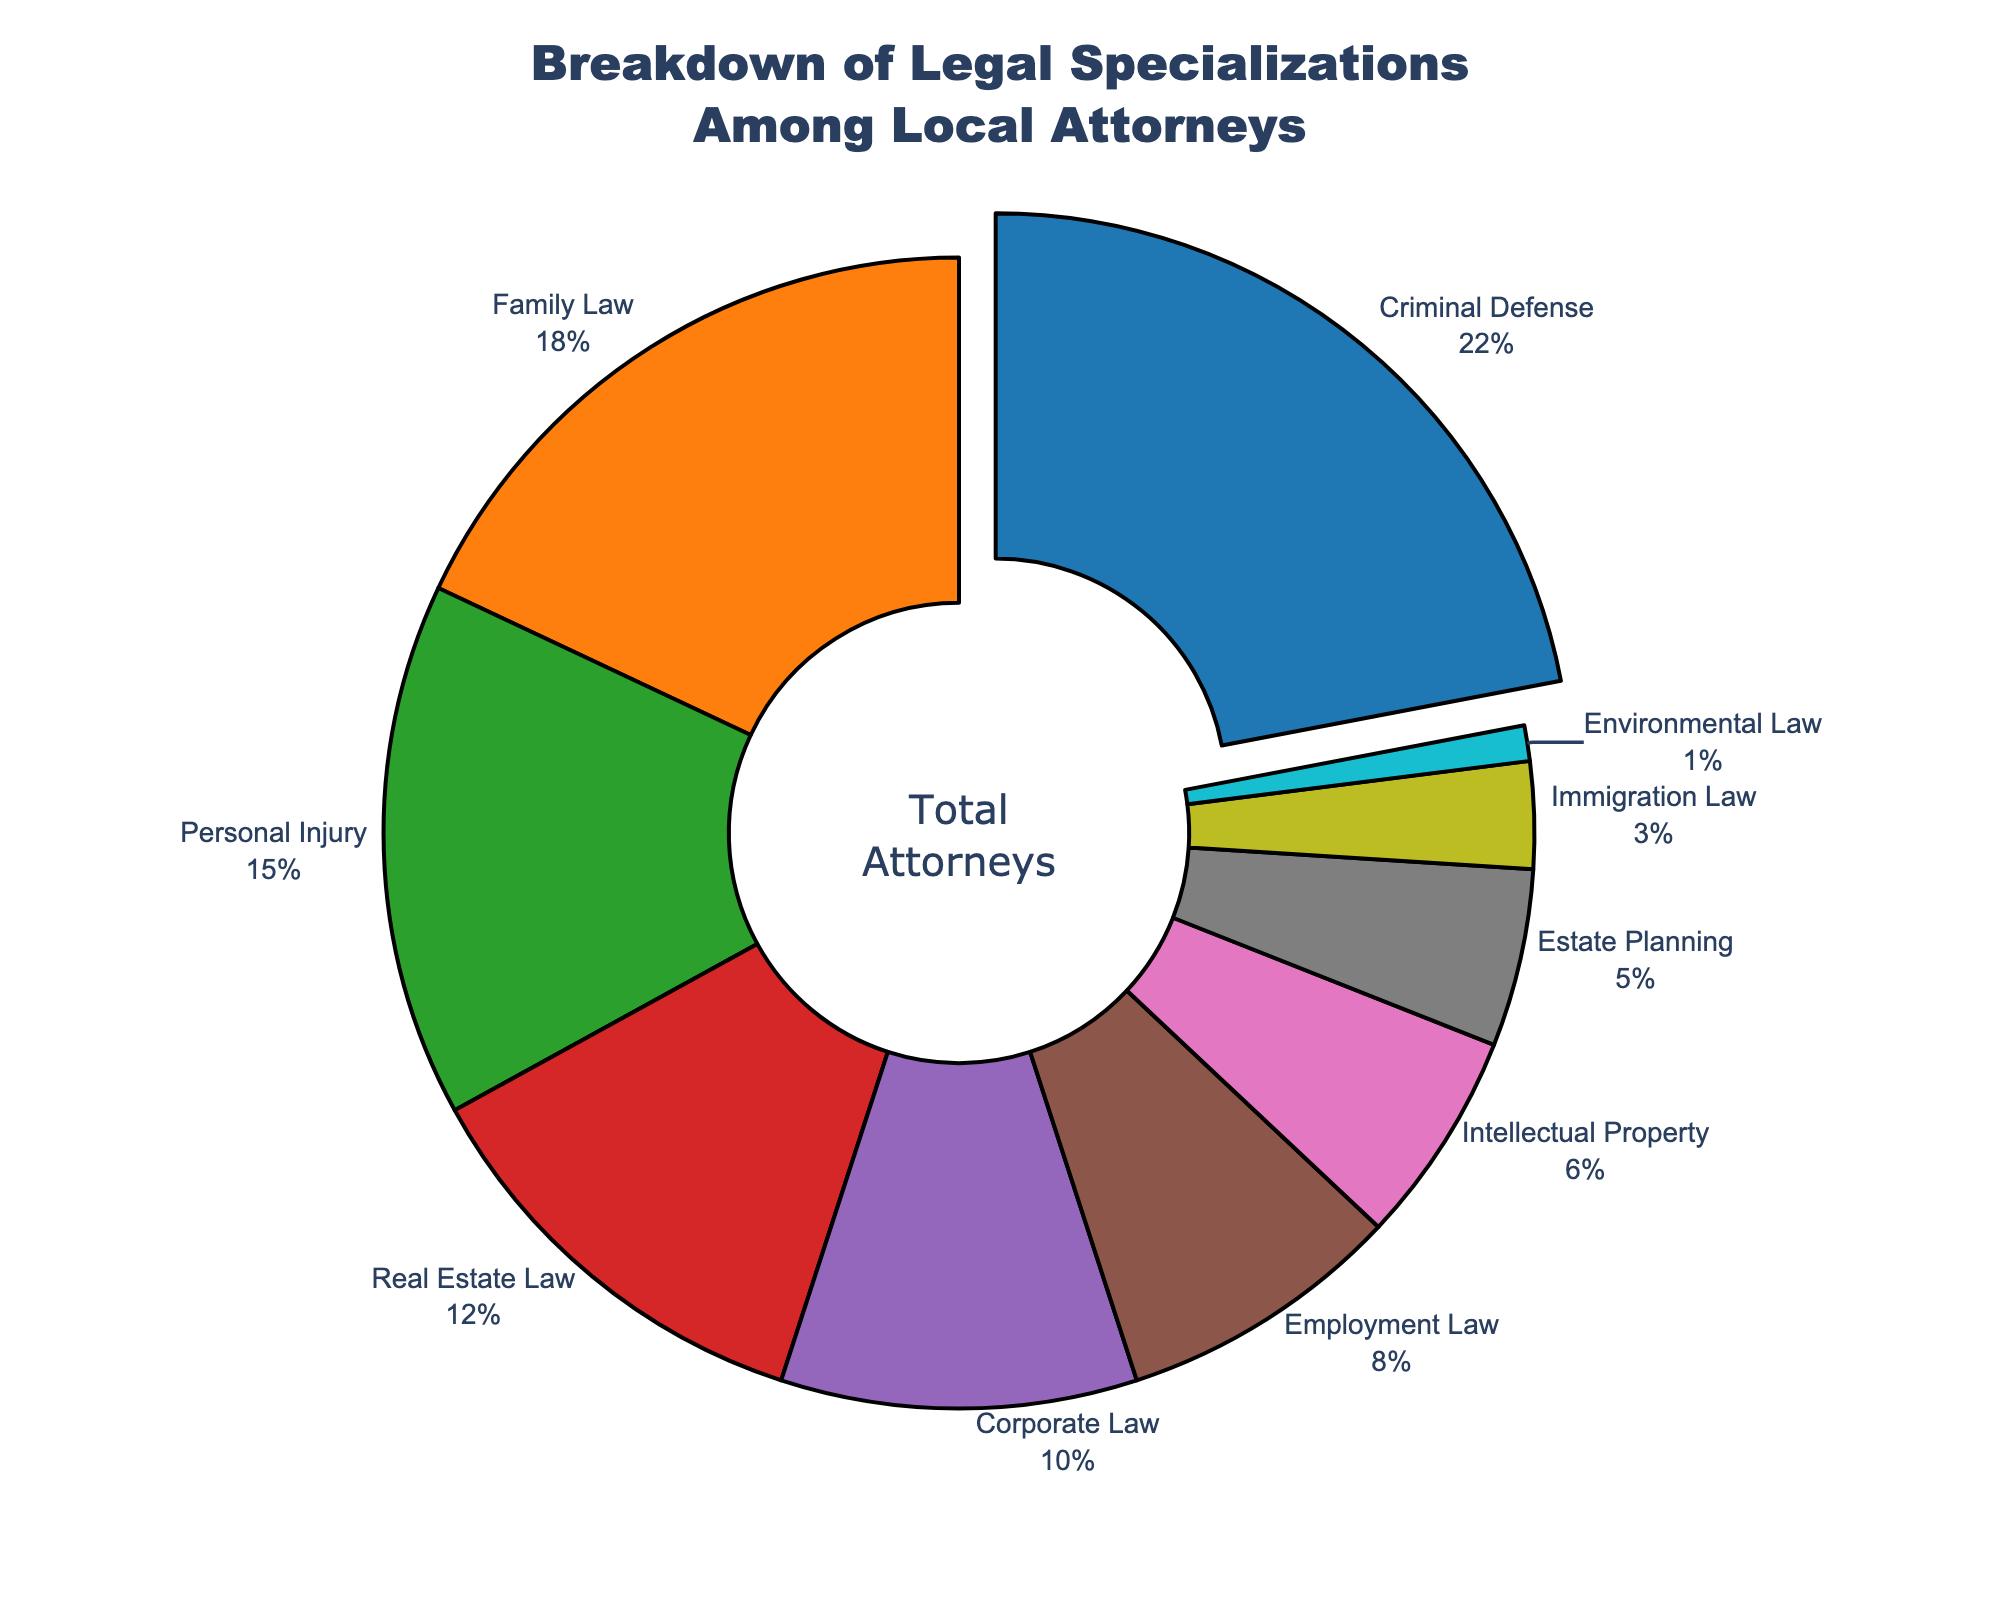How many legal specializations have a percentage higher than 10%? By referring to the figure, we identify which slices in the pie chart represent percentages higher than 10%. These specializations are Criminal Defense (22%), Family Law (18%), Personal Injury (15%), and Real Estate Law (12%). There are 4 such specializations.
Answer: 4 Which legal specialization has the largest percentage of local attorneys? By examining the pie chart, we notice that the largest slice is for Criminal Defense, which has a percentage of 22%.
Answer: Criminal Defense What is the sum percentage of Family Law, Employment Law, and Estate Planning combined? We add the percentages for each specialization: Family Law (18%), Employment Law (8%), and Estate Planning (5%). The sum is 18% + 8% + 5% = 31%.
Answer: 31% Which specialization occupies the smallest slice of the pie chart? The smallest slice in the pie chart is represented by Environmental Law, which has a percentage of 1%.
Answer: Environmental Law Among Immigration Law and Real Estate Law, which one has a larger percentage? By comparing the two slices in the pie chart, Immigration Law (3%) and Real Estate Law (12%), it is evident that Real Estate Law has a larger percentage.
Answer: Real Estate Law How does the percentage of Corporate Law compare to that of Intellectual Property? Examining the pie chart slices, Corporate Law has 10% while Intellectual Property has 6%. Corporate Law has a larger percentage.
Answer: Corporate Law What is the combined percentage of the three least common legal specializations? The three least common specializations are Immigration Law (3%), Estate Planning (5%), and Environmental Law (1%). Their combined percentage is 3% + 5% + 1% = 9%.
Answer: 9% What color represents Criminal Defense in the pie chart? By observing the color legend and the pie chart, Criminal Defense is represented by the color blue.
Answer: Blue If we combine the percentages of Criminal Defense and Personal Injury, does their total exceed 35%? Adding the percentages of Criminal Defense (22%) and Personal Injury (15%) gives us 22% + 15% = 37%. Yes, the total exceeds 35%.
Answer: Yes Which specialization has a percentage that's closest to the overall average percentage of all specializations? First, calculate the average percentage by summing all the percentages (22 + 18 + 15 + 12 + 10 + 8 + 6 + 5 + 3 + 1 = 100) and then dividing by the number of specializations (10). The average is 100/10 = 10%. By examining the pie chart, Corporate Law has a percentage of 10%, which is closest to the average.
Answer: Corporate Law 